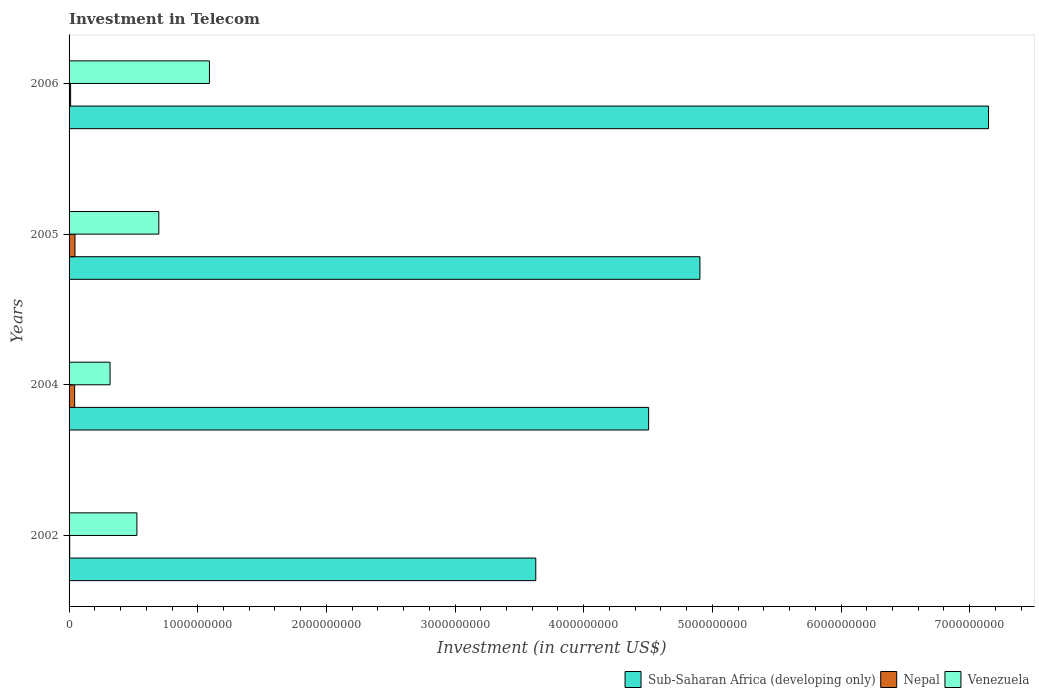How many different coloured bars are there?
Offer a terse response. 3. How many bars are there on the 1st tick from the top?
Your response must be concise. 3. How many bars are there on the 1st tick from the bottom?
Provide a short and direct response. 3. What is the label of the 1st group of bars from the top?
Ensure brevity in your answer.  2006. What is the amount invested in telecom in Nepal in 2002?
Your answer should be compact. 4.90e+06. Across all years, what is the maximum amount invested in telecom in Sub-Saharan Africa (developing only)?
Ensure brevity in your answer.  7.15e+09. Across all years, what is the minimum amount invested in telecom in Venezuela?
Your answer should be compact. 3.18e+08. In which year was the amount invested in telecom in Nepal minimum?
Offer a terse response. 2002. What is the total amount invested in telecom in Nepal in the graph?
Give a very brief answer. 1.06e+08. What is the difference between the amount invested in telecom in Venezuela in 2002 and that in 2006?
Ensure brevity in your answer.  -5.64e+08. What is the difference between the amount invested in telecom in Nepal in 2005 and the amount invested in telecom in Venezuela in 2002?
Provide a succinct answer. -4.81e+08. What is the average amount invested in telecom in Nepal per year?
Offer a very short reply. 2.66e+07. In the year 2004, what is the difference between the amount invested in telecom in Sub-Saharan Africa (developing only) and amount invested in telecom in Nepal?
Provide a succinct answer. 4.46e+09. What is the ratio of the amount invested in telecom in Venezuela in 2002 to that in 2004?
Your response must be concise. 1.66. What is the difference between the highest and the second highest amount invested in telecom in Venezuela?
Your answer should be compact. 3.94e+08. What is the difference between the highest and the lowest amount invested in telecom in Sub-Saharan Africa (developing only)?
Make the answer very short. 3.52e+09. What does the 2nd bar from the top in 2002 represents?
Your answer should be very brief. Nepal. What does the 1st bar from the bottom in 2002 represents?
Offer a terse response. Sub-Saharan Africa (developing only). How many bars are there?
Your answer should be very brief. 12. Are all the bars in the graph horizontal?
Your answer should be very brief. Yes. Are the values on the major ticks of X-axis written in scientific E-notation?
Offer a terse response. No. What is the title of the graph?
Your response must be concise. Investment in Telecom. Does "Monaco" appear as one of the legend labels in the graph?
Ensure brevity in your answer.  No. What is the label or title of the X-axis?
Provide a short and direct response. Investment (in current US$). What is the label or title of the Y-axis?
Your answer should be very brief. Years. What is the Investment (in current US$) in Sub-Saharan Africa (developing only) in 2002?
Your response must be concise. 3.63e+09. What is the Investment (in current US$) in Nepal in 2002?
Give a very brief answer. 4.90e+06. What is the Investment (in current US$) of Venezuela in 2002?
Offer a terse response. 5.27e+08. What is the Investment (in current US$) of Sub-Saharan Africa (developing only) in 2004?
Your answer should be compact. 4.50e+09. What is the Investment (in current US$) in Nepal in 2004?
Your answer should be very brief. 4.33e+07. What is the Investment (in current US$) of Venezuela in 2004?
Give a very brief answer. 3.18e+08. What is the Investment (in current US$) of Sub-Saharan Africa (developing only) in 2005?
Ensure brevity in your answer.  4.90e+09. What is the Investment (in current US$) of Nepal in 2005?
Ensure brevity in your answer.  4.60e+07. What is the Investment (in current US$) of Venezuela in 2005?
Give a very brief answer. 6.98e+08. What is the Investment (in current US$) of Sub-Saharan Africa (developing only) in 2006?
Make the answer very short. 7.15e+09. What is the Investment (in current US$) of Nepal in 2006?
Your response must be concise. 1.20e+07. What is the Investment (in current US$) in Venezuela in 2006?
Ensure brevity in your answer.  1.09e+09. Across all years, what is the maximum Investment (in current US$) of Sub-Saharan Africa (developing only)?
Your response must be concise. 7.15e+09. Across all years, what is the maximum Investment (in current US$) in Nepal?
Make the answer very short. 4.60e+07. Across all years, what is the maximum Investment (in current US$) in Venezuela?
Offer a terse response. 1.09e+09. Across all years, what is the minimum Investment (in current US$) in Sub-Saharan Africa (developing only)?
Make the answer very short. 3.63e+09. Across all years, what is the minimum Investment (in current US$) of Nepal?
Provide a succinct answer. 4.90e+06. Across all years, what is the minimum Investment (in current US$) in Venezuela?
Ensure brevity in your answer.  3.18e+08. What is the total Investment (in current US$) of Sub-Saharan Africa (developing only) in the graph?
Offer a very short reply. 2.02e+1. What is the total Investment (in current US$) of Nepal in the graph?
Your answer should be compact. 1.06e+08. What is the total Investment (in current US$) in Venezuela in the graph?
Offer a terse response. 2.63e+09. What is the difference between the Investment (in current US$) of Sub-Saharan Africa (developing only) in 2002 and that in 2004?
Provide a succinct answer. -8.77e+08. What is the difference between the Investment (in current US$) of Nepal in 2002 and that in 2004?
Make the answer very short. -3.84e+07. What is the difference between the Investment (in current US$) of Venezuela in 2002 and that in 2004?
Ensure brevity in your answer.  2.09e+08. What is the difference between the Investment (in current US$) of Sub-Saharan Africa (developing only) in 2002 and that in 2005?
Your response must be concise. -1.28e+09. What is the difference between the Investment (in current US$) in Nepal in 2002 and that in 2005?
Offer a terse response. -4.11e+07. What is the difference between the Investment (in current US$) of Venezuela in 2002 and that in 2005?
Offer a terse response. -1.70e+08. What is the difference between the Investment (in current US$) in Sub-Saharan Africa (developing only) in 2002 and that in 2006?
Your answer should be compact. -3.52e+09. What is the difference between the Investment (in current US$) in Nepal in 2002 and that in 2006?
Provide a short and direct response. -7.10e+06. What is the difference between the Investment (in current US$) of Venezuela in 2002 and that in 2006?
Ensure brevity in your answer.  -5.64e+08. What is the difference between the Investment (in current US$) in Sub-Saharan Africa (developing only) in 2004 and that in 2005?
Your answer should be compact. -3.99e+08. What is the difference between the Investment (in current US$) of Nepal in 2004 and that in 2005?
Your response must be concise. -2.70e+06. What is the difference between the Investment (in current US$) in Venezuela in 2004 and that in 2005?
Provide a short and direct response. -3.79e+08. What is the difference between the Investment (in current US$) in Sub-Saharan Africa (developing only) in 2004 and that in 2006?
Provide a succinct answer. -2.64e+09. What is the difference between the Investment (in current US$) of Nepal in 2004 and that in 2006?
Your response must be concise. 3.13e+07. What is the difference between the Investment (in current US$) of Venezuela in 2004 and that in 2006?
Your answer should be compact. -7.72e+08. What is the difference between the Investment (in current US$) of Sub-Saharan Africa (developing only) in 2005 and that in 2006?
Make the answer very short. -2.24e+09. What is the difference between the Investment (in current US$) in Nepal in 2005 and that in 2006?
Your response must be concise. 3.40e+07. What is the difference between the Investment (in current US$) in Venezuela in 2005 and that in 2006?
Keep it short and to the point. -3.94e+08. What is the difference between the Investment (in current US$) in Sub-Saharan Africa (developing only) in 2002 and the Investment (in current US$) in Nepal in 2004?
Keep it short and to the point. 3.58e+09. What is the difference between the Investment (in current US$) in Sub-Saharan Africa (developing only) in 2002 and the Investment (in current US$) in Venezuela in 2004?
Give a very brief answer. 3.31e+09. What is the difference between the Investment (in current US$) of Nepal in 2002 and the Investment (in current US$) of Venezuela in 2004?
Keep it short and to the point. -3.14e+08. What is the difference between the Investment (in current US$) in Sub-Saharan Africa (developing only) in 2002 and the Investment (in current US$) in Nepal in 2005?
Offer a very short reply. 3.58e+09. What is the difference between the Investment (in current US$) in Sub-Saharan Africa (developing only) in 2002 and the Investment (in current US$) in Venezuela in 2005?
Offer a very short reply. 2.93e+09. What is the difference between the Investment (in current US$) of Nepal in 2002 and the Investment (in current US$) of Venezuela in 2005?
Your response must be concise. -6.93e+08. What is the difference between the Investment (in current US$) of Sub-Saharan Africa (developing only) in 2002 and the Investment (in current US$) of Nepal in 2006?
Ensure brevity in your answer.  3.62e+09. What is the difference between the Investment (in current US$) in Sub-Saharan Africa (developing only) in 2002 and the Investment (in current US$) in Venezuela in 2006?
Make the answer very short. 2.54e+09. What is the difference between the Investment (in current US$) in Nepal in 2002 and the Investment (in current US$) in Venezuela in 2006?
Provide a short and direct response. -1.09e+09. What is the difference between the Investment (in current US$) of Sub-Saharan Africa (developing only) in 2004 and the Investment (in current US$) of Nepal in 2005?
Make the answer very short. 4.46e+09. What is the difference between the Investment (in current US$) in Sub-Saharan Africa (developing only) in 2004 and the Investment (in current US$) in Venezuela in 2005?
Your response must be concise. 3.81e+09. What is the difference between the Investment (in current US$) of Nepal in 2004 and the Investment (in current US$) of Venezuela in 2005?
Your answer should be compact. -6.54e+08. What is the difference between the Investment (in current US$) of Sub-Saharan Africa (developing only) in 2004 and the Investment (in current US$) of Nepal in 2006?
Offer a very short reply. 4.49e+09. What is the difference between the Investment (in current US$) of Sub-Saharan Africa (developing only) in 2004 and the Investment (in current US$) of Venezuela in 2006?
Your answer should be compact. 3.41e+09. What is the difference between the Investment (in current US$) in Nepal in 2004 and the Investment (in current US$) in Venezuela in 2006?
Ensure brevity in your answer.  -1.05e+09. What is the difference between the Investment (in current US$) of Sub-Saharan Africa (developing only) in 2005 and the Investment (in current US$) of Nepal in 2006?
Ensure brevity in your answer.  4.89e+09. What is the difference between the Investment (in current US$) in Sub-Saharan Africa (developing only) in 2005 and the Investment (in current US$) in Venezuela in 2006?
Provide a succinct answer. 3.81e+09. What is the difference between the Investment (in current US$) of Nepal in 2005 and the Investment (in current US$) of Venezuela in 2006?
Ensure brevity in your answer.  -1.04e+09. What is the average Investment (in current US$) of Sub-Saharan Africa (developing only) per year?
Your answer should be compact. 5.05e+09. What is the average Investment (in current US$) of Nepal per year?
Your answer should be very brief. 2.66e+07. What is the average Investment (in current US$) in Venezuela per year?
Provide a short and direct response. 6.59e+08. In the year 2002, what is the difference between the Investment (in current US$) of Sub-Saharan Africa (developing only) and Investment (in current US$) of Nepal?
Your answer should be compact. 3.62e+09. In the year 2002, what is the difference between the Investment (in current US$) in Sub-Saharan Africa (developing only) and Investment (in current US$) in Venezuela?
Keep it short and to the point. 3.10e+09. In the year 2002, what is the difference between the Investment (in current US$) in Nepal and Investment (in current US$) in Venezuela?
Provide a succinct answer. -5.22e+08. In the year 2004, what is the difference between the Investment (in current US$) in Sub-Saharan Africa (developing only) and Investment (in current US$) in Nepal?
Offer a very short reply. 4.46e+09. In the year 2004, what is the difference between the Investment (in current US$) of Sub-Saharan Africa (developing only) and Investment (in current US$) of Venezuela?
Provide a succinct answer. 4.19e+09. In the year 2004, what is the difference between the Investment (in current US$) of Nepal and Investment (in current US$) of Venezuela?
Keep it short and to the point. -2.75e+08. In the year 2005, what is the difference between the Investment (in current US$) of Sub-Saharan Africa (developing only) and Investment (in current US$) of Nepal?
Give a very brief answer. 4.86e+09. In the year 2005, what is the difference between the Investment (in current US$) in Sub-Saharan Africa (developing only) and Investment (in current US$) in Venezuela?
Your answer should be very brief. 4.21e+09. In the year 2005, what is the difference between the Investment (in current US$) in Nepal and Investment (in current US$) in Venezuela?
Your response must be concise. -6.52e+08. In the year 2006, what is the difference between the Investment (in current US$) in Sub-Saharan Africa (developing only) and Investment (in current US$) in Nepal?
Make the answer very short. 7.13e+09. In the year 2006, what is the difference between the Investment (in current US$) in Sub-Saharan Africa (developing only) and Investment (in current US$) in Venezuela?
Your answer should be compact. 6.06e+09. In the year 2006, what is the difference between the Investment (in current US$) in Nepal and Investment (in current US$) in Venezuela?
Make the answer very short. -1.08e+09. What is the ratio of the Investment (in current US$) of Sub-Saharan Africa (developing only) in 2002 to that in 2004?
Provide a succinct answer. 0.81. What is the ratio of the Investment (in current US$) in Nepal in 2002 to that in 2004?
Ensure brevity in your answer.  0.11. What is the ratio of the Investment (in current US$) in Venezuela in 2002 to that in 2004?
Make the answer very short. 1.66. What is the ratio of the Investment (in current US$) in Sub-Saharan Africa (developing only) in 2002 to that in 2005?
Keep it short and to the point. 0.74. What is the ratio of the Investment (in current US$) of Nepal in 2002 to that in 2005?
Keep it short and to the point. 0.11. What is the ratio of the Investment (in current US$) in Venezuela in 2002 to that in 2005?
Make the answer very short. 0.76. What is the ratio of the Investment (in current US$) in Sub-Saharan Africa (developing only) in 2002 to that in 2006?
Offer a terse response. 0.51. What is the ratio of the Investment (in current US$) of Nepal in 2002 to that in 2006?
Your answer should be very brief. 0.41. What is the ratio of the Investment (in current US$) in Venezuela in 2002 to that in 2006?
Keep it short and to the point. 0.48. What is the ratio of the Investment (in current US$) in Sub-Saharan Africa (developing only) in 2004 to that in 2005?
Ensure brevity in your answer.  0.92. What is the ratio of the Investment (in current US$) of Nepal in 2004 to that in 2005?
Ensure brevity in your answer.  0.94. What is the ratio of the Investment (in current US$) in Venezuela in 2004 to that in 2005?
Offer a very short reply. 0.46. What is the ratio of the Investment (in current US$) of Sub-Saharan Africa (developing only) in 2004 to that in 2006?
Make the answer very short. 0.63. What is the ratio of the Investment (in current US$) of Nepal in 2004 to that in 2006?
Your answer should be compact. 3.61. What is the ratio of the Investment (in current US$) in Venezuela in 2004 to that in 2006?
Your answer should be compact. 0.29. What is the ratio of the Investment (in current US$) of Sub-Saharan Africa (developing only) in 2005 to that in 2006?
Ensure brevity in your answer.  0.69. What is the ratio of the Investment (in current US$) of Nepal in 2005 to that in 2006?
Ensure brevity in your answer.  3.83. What is the ratio of the Investment (in current US$) of Venezuela in 2005 to that in 2006?
Ensure brevity in your answer.  0.64. What is the difference between the highest and the second highest Investment (in current US$) of Sub-Saharan Africa (developing only)?
Provide a succinct answer. 2.24e+09. What is the difference between the highest and the second highest Investment (in current US$) of Nepal?
Offer a very short reply. 2.70e+06. What is the difference between the highest and the second highest Investment (in current US$) in Venezuela?
Offer a very short reply. 3.94e+08. What is the difference between the highest and the lowest Investment (in current US$) in Sub-Saharan Africa (developing only)?
Your answer should be compact. 3.52e+09. What is the difference between the highest and the lowest Investment (in current US$) of Nepal?
Your answer should be compact. 4.11e+07. What is the difference between the highest and the lowest Investment (in current US$) of Venezuela?
Provide a succinct answer. 7.72e+08. 